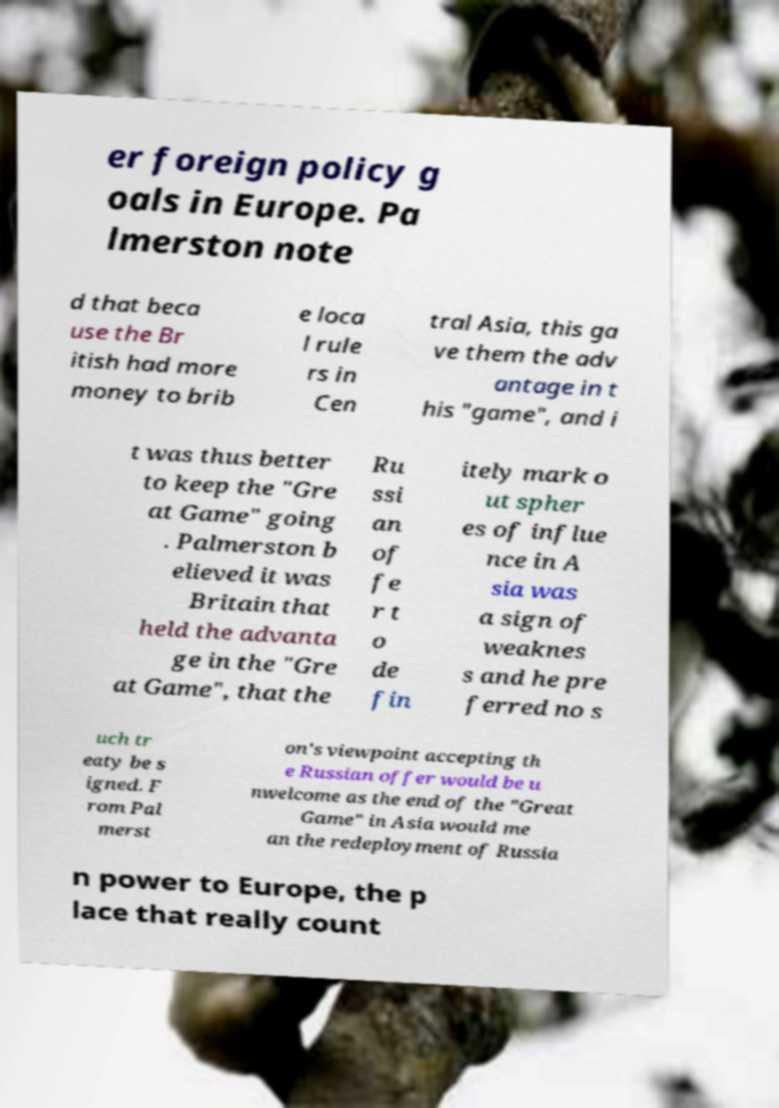What messages or text are displayed in this image? I need them in a readable, typed format. er foreign policy g oals in Europe. Pa lmerston note d that beca use the Br itish had more money to brib e loca l rule rs in Cen tral Asia, this ga ve them the adv antage in t his "game", and i t was thus better to keep the "Gre at Game" going . Palmerston b elieved it was Britain that held the advanta ge in the "Gre at Game", that the Ru ssi an of fe r t o de fin itely mark o ut spher es of influe nce in A sia was a sign of weaknes s and he pre ferred no s uch tr eaty be s igned. F rom Pal merst on's viewpoint accepting th e Russian offer would be u nwelcome as the end of the "Great Game" in Asia would me an the redeployment of Russia n power to Europe, the p lace that really count 